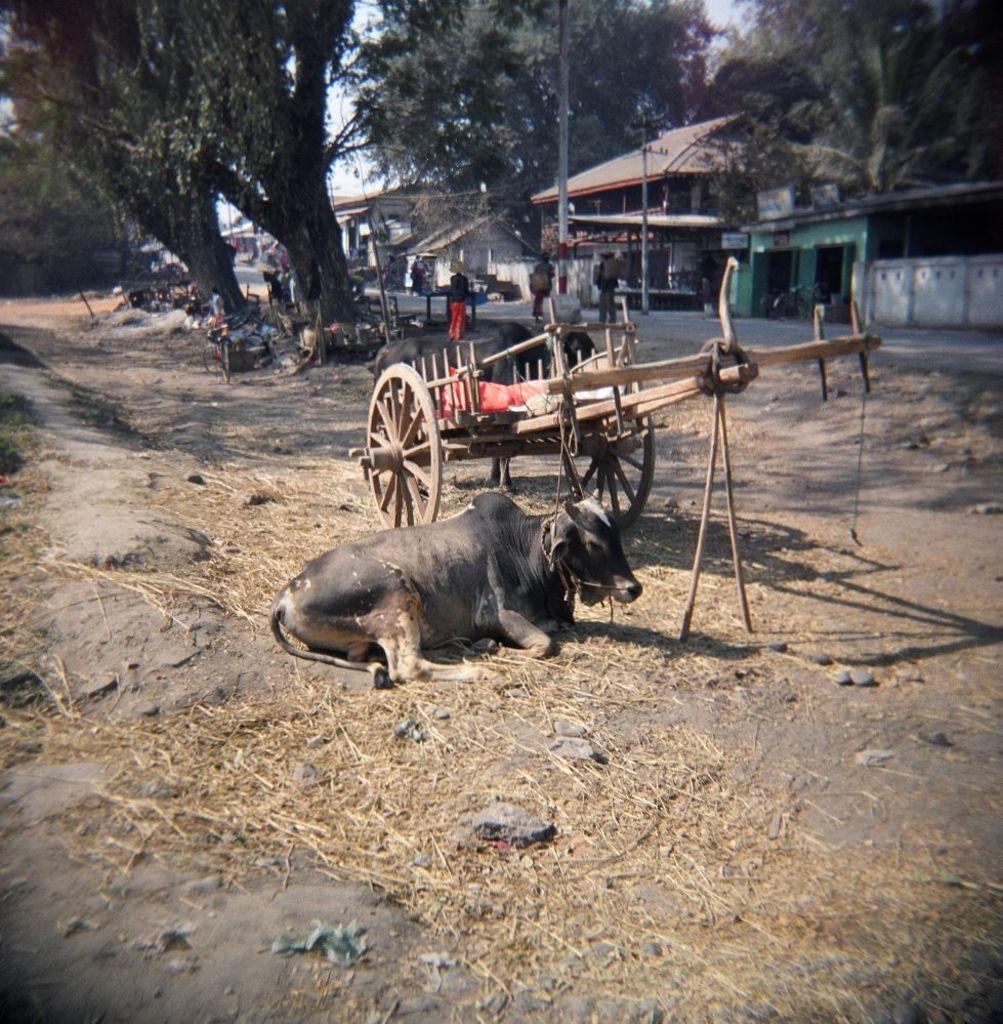Can you describe this image briefly? In this picture there is a cow and a cart in the center of the image and there is dry grass on the floor and there are people, houses, and trees in the background area of the image. 